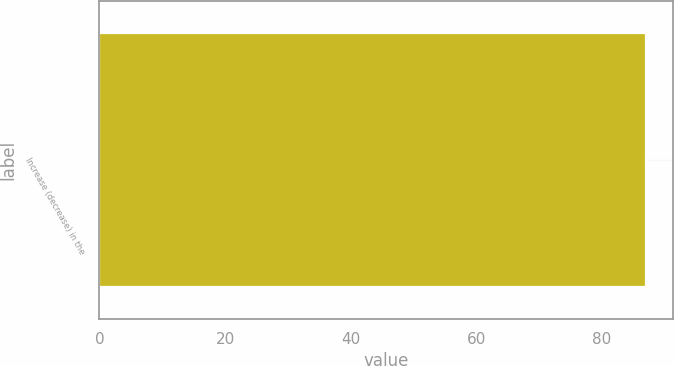<chart> <loc_0><loc_0><loc_500><loc_500><bar_chart><fcel>Increase (decrease) in the<nl><fcel>87<nl></chart> 